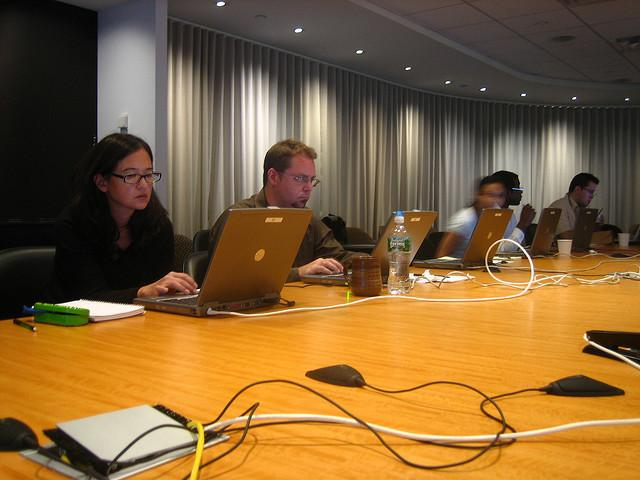What are the people doing in this venue? Please explain your reasoning. working. The setting is of a professional board room nature. the laptops are the same brand/design and each have a sticker tag. 